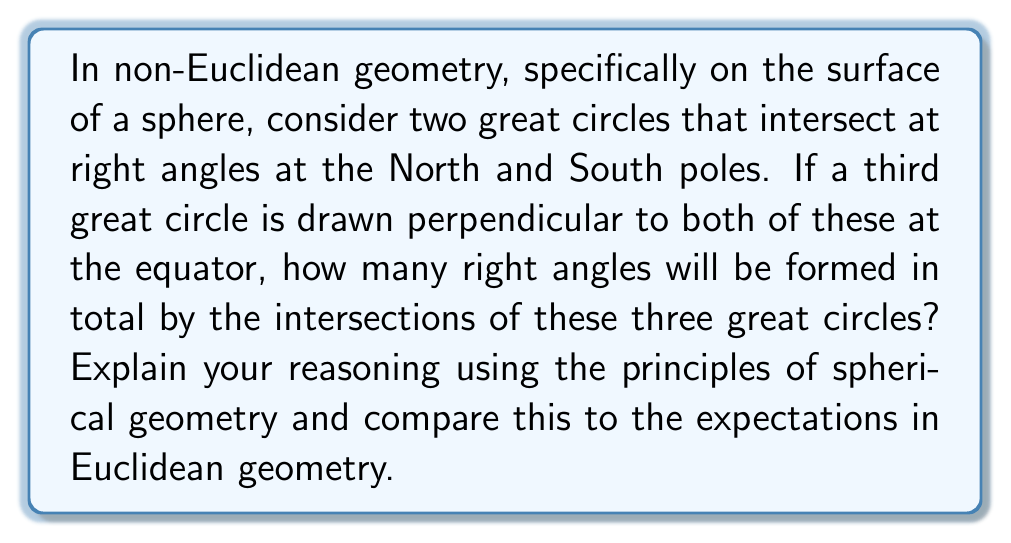Can you solve this math problem? Let's approach this step-by-step:

1) First, recall that in Euclidean geometry, the sum of angles in a triangle is always 180°, and parallel lines never intersect.

2) However, on a sphere (a non-Euclidean surface), these rules don't apply. Great circles on a sphere are analogous to straight lines in a plane.

3) Let's visualize the scenario:
   [asy]
   import geometry;
   
   size(200);
   draw(circle((0,0),1),blue);
   draw(arc((0,0),1,90,270),red);
   draw(arc((0,0),1,0,180),green);
   draw(circle((0,0),1,90),purple);
   
   dot((0,1),black);
   dot((0,-1),black);
   dot((1,0),black);
   dot((-1,0),black);
   dot((0,0),black);
   
   label("N",(0,1.1),N);
   label("S",(0,-1.1),S);
   label("E",(1.1,0),E);
   label("W",(-1.1,0),W);
   [/asy]

4) The first two great circles (red and green) intersect at right angles at the North and South poles. This forms 4 right angles.

5) The third great circle (purple) is perpendicular to both at the equator. This forms 4 more right angles where it intersects each of the first two circles.

6) Additionally, this third circle also intersects the first two at the antipodal points on the equator (E and W in the diagram), forming 4 more right angles.

7) In total, we have:
   - 4 right angles at the poles
   - 4 right angles at the equator
   - 4 right angles at the antipodal points on the equator

8) Therefore, the total number of right angles formed is 4 + 4 + 4 = 12.

9) This is in stark contrast to Euclidean geometry, where three mutually perpendicular lines would form only 6 right angles at their intersections.

This demonstrates how non-Euclidean geometry challenges our intuitive understanding of space based on Euclidean principles, illustrating the profound impact of non-Euclidean geometry on our comprehension of spatial relationships.
Answer: 12 right angles 